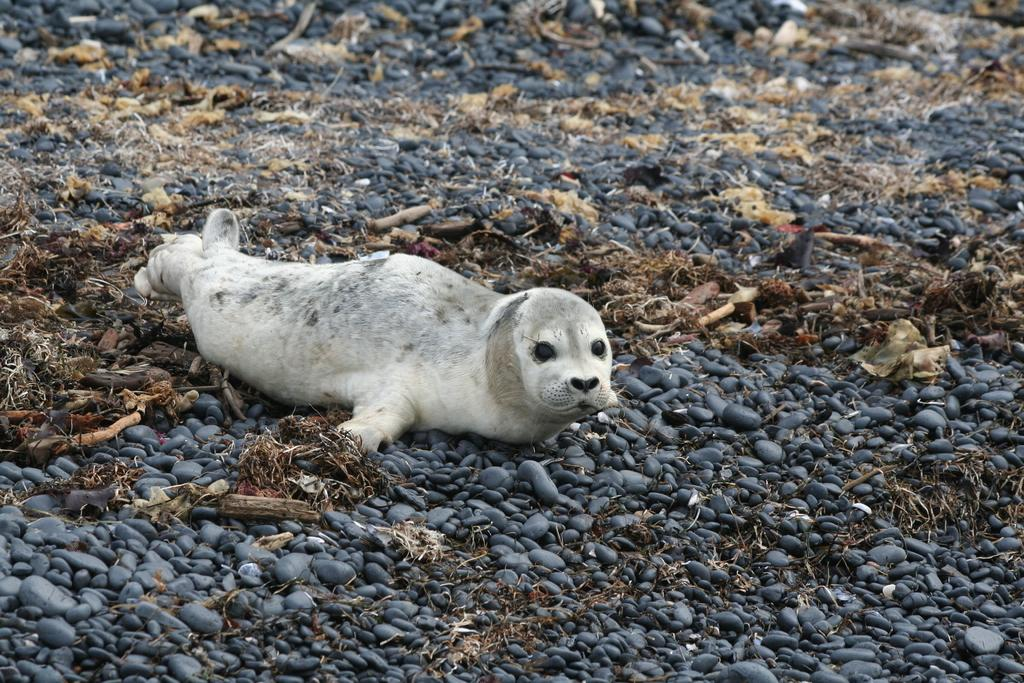What type of animal can be seen in the image? There is an animal in the image, but its specific type cannot be determined from the provided facts. What is the animal standing on in the image? The animal is on stones in the image. What type of vegetation is present in the image? There is grass in the image. What else can be seen in the image besides the animal and grass? There are objects in the image, but their specific nature cannot be determined from the provided facts. Can you describe the animal's breathing pattern in the image? There is no information about the animal's breathing pattern in the image. What type of ship is visible in the image? There is no ship present in the image. 